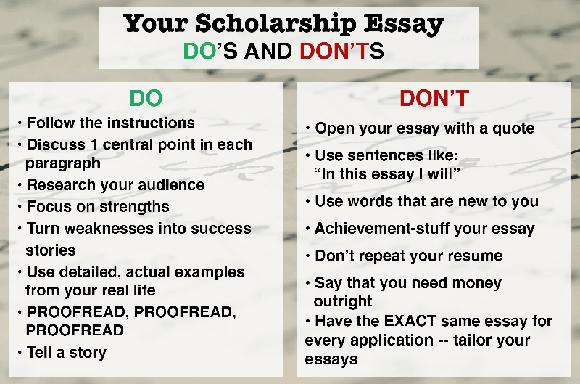Can you suggest an opening statement for a scholarship essay that aligns with the DO's listed in the image? Certainly! You might start your essay with: 'Through my volunteer work with local community gardens, I've cultivated not only plants but also my own resilience and leadership skills, setting the foundation for my environmental science ambitions.' This opening reflects a personal story, adheres to the instruction of using real-life examples, and avoids cliches or quotations. 